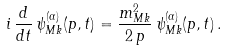<formula> <loc_0><loc_0><loc_500><loc_500>i \, \frac { d } { d t } \, \psi ^ { ( \alpha ) } _ { M k } ( p , t ) = \frac { m ^ { 2 } _ { M k } } { 2 \, p } \, \psi ^ { ( \alpha ) } _ { M k } ( p , t ) \, .</formula> 